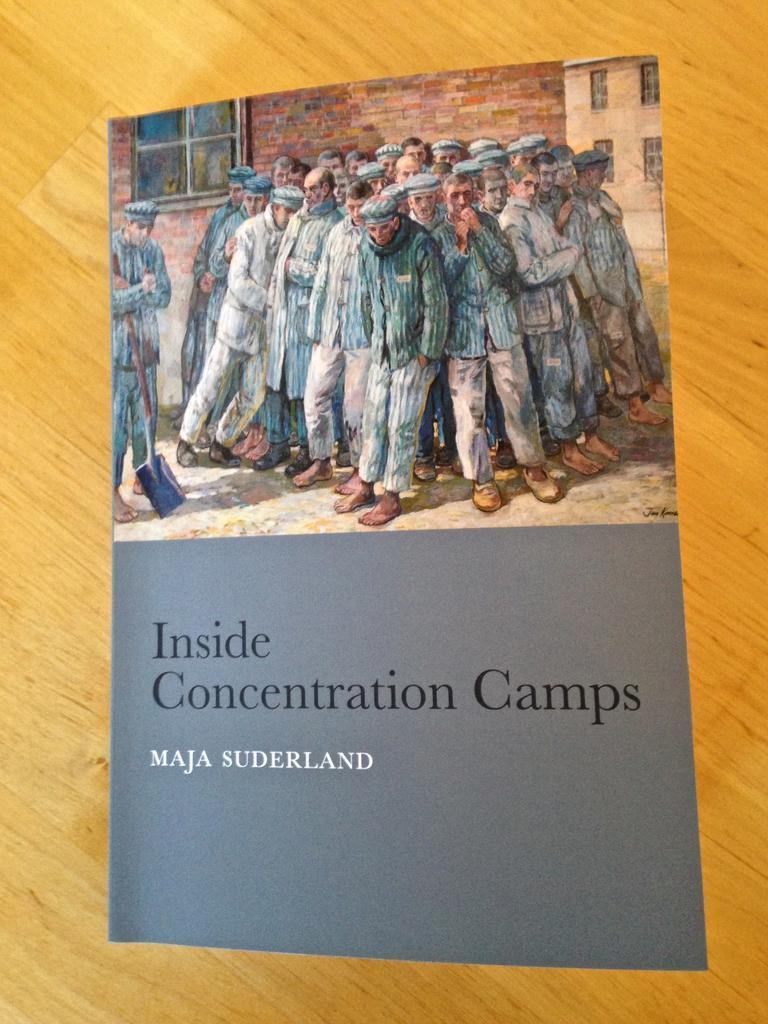How would you summarize this image in a sentence or two? In the foreground of this image, there is a book on the wooden surface and on the book, there is painting of persons standing and text is on the bottom. 